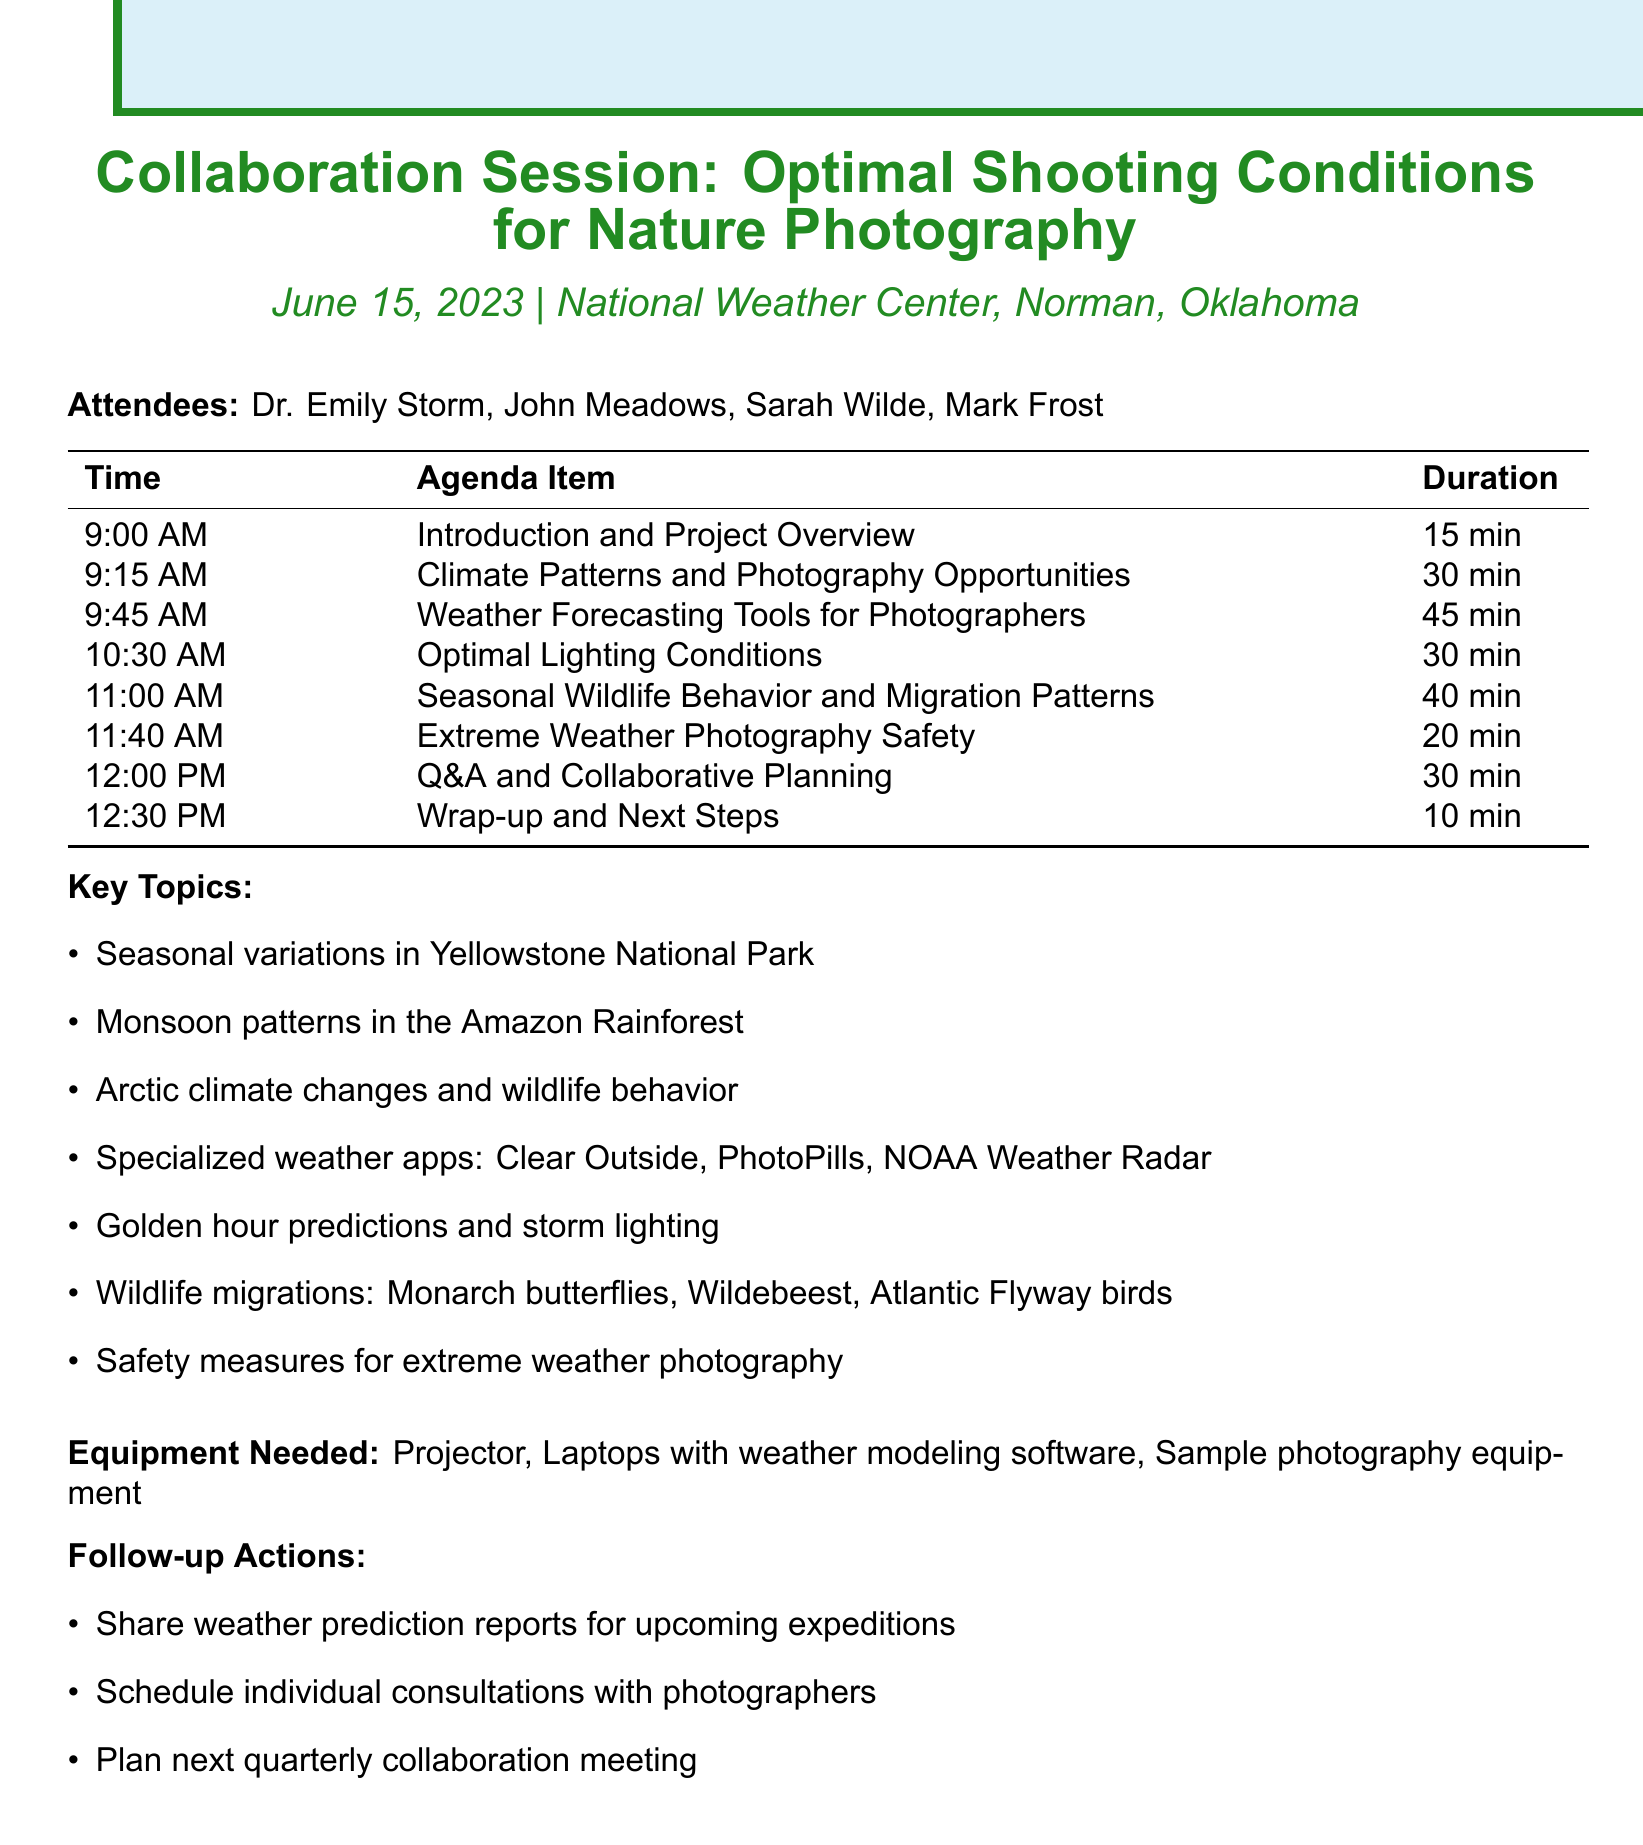What is the date of the meeting? The date is specified in the document, which is June 15, 2023.
Answer: June 15, 2023 Where is the meeting located? The location of the meeting is mentioned in the document as the National Weather Center, Norman, Oklahoma.
Answer: National Weather Center, Norman, Oklahoma How long is the "Weather Forecasting Tools for Photographers" agenda item? The duration for this agenda item is provided in the document.
Answer: 45 minutes Who is one of the attendees of the session? The document lists attendees, and one is Dr. Emily Storm.
Answer: Dr. Emily Storm What are two examples of wildlife migrations discussed? This requires reasoning between wildlife behaviors and the mentioned examples in the document.
Answer: Monarch butterfly migration, Wildebeest migration What is one tool that will be demonstrated for photographers? The document explicitly lists tools for weather forecasting, such as the Clear Outside app.
Answer: Clear Outside app What is the main focus of the "Extreme Weather Photography Safety" agenda item? The document mentions guidelines and safety measures as the main focus of this item.
Answer: Guidelines and safety measures What is one follow-up action mentioned in the document? The document lists follow-up actions, one being to share weather prediction reports.
Answer: Share weather prediction reports 